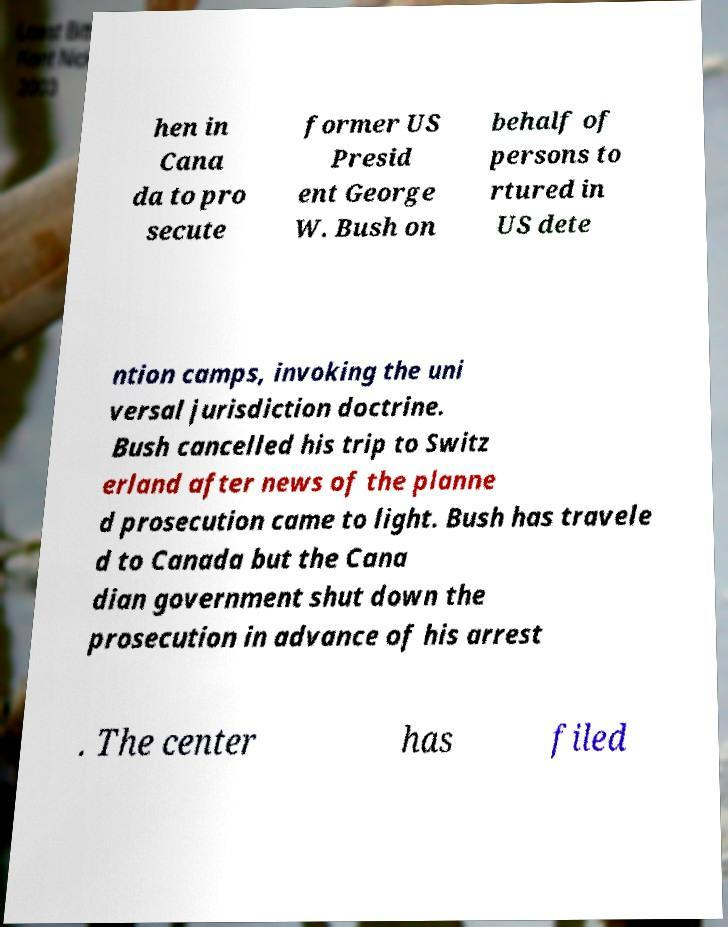Can you read and provide the text displayed in the image?This photo seems to have some interesting text. Can you extract and type it out for me? hen in Cana da to pro secute former US Presid ent George W. Bush on behalf of persons to rtured in US dete ntion camps, invoking the uni versal jurisdiction doctrine. Bush cancelled his trip to Switz erland after news of the planne d prosecution came to light. Bush has travele d to Canada but the Cana dian government shut down the prosecution in advance of his arrest . The center has filed 